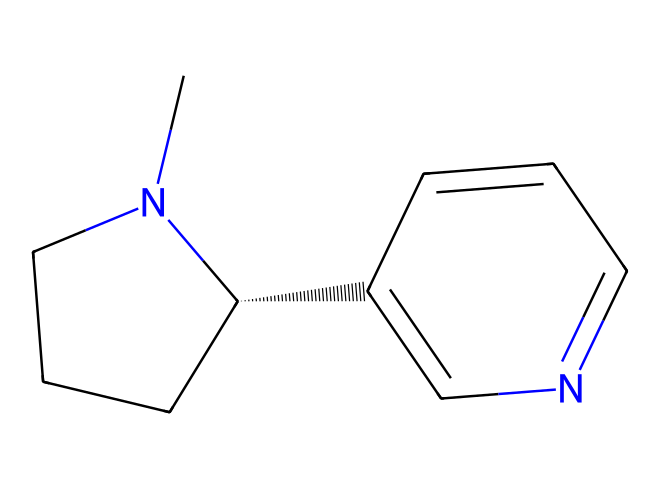What is the molecular formula of nicotine? The molecular structure can be analyzed to count the elements present. The structure shows 10 carbon atoms (C), 14 hydrogen atoms (H), and 2 nitrogen atoms (N), leading to the formula C10H14N2.
Answer: C10H14N2 How many rings are present in the nicotine structure? By examining the structure closely, there are two distinct ring systems in the nicotine molecule. The presence of cycles in the structural representation indicates this.
Answer: 2 What type of chemical is nicotine classified as? Nicotine is classified as an alkaloid based on its structure, which contains a basic nitrogen atom and is derived from a plant source, specifically tobacco.
Answer: alkaloid Which functional group is present in nicotine? The presence of the nitrogen atom in a cyclic structure suggests that nicotine contains an amine functional group. The cyclic structure indicates where the amine is incorporated.
Answer: amine What effect does nicotine have on the nervous system? Nicotine acts as a stimulant on the nervous system, which is well-documented in various scientific studies regarding its impact on neurotransmitter release.
Answer: stimulant How many nitrogen atoms are found in nicotine? The chemical structure indicates two nitrogen atoms through the analysis of the formula and the visual representation of the molecule.
Answer: 2 What characteristic taste is associated with nicotine and why? The nitrogen content in nicotine contributes to its bitter taste, as alkaloids are commonly known for having a bitter flavor due to their nitrogen atoms.
Answer: bitter 